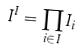Convert formula to latex. <formula><loc_0><loc_0><loc_500><loc_500>I ^ { I } = \prod _ { i \in I } I _ { i }</formula> 